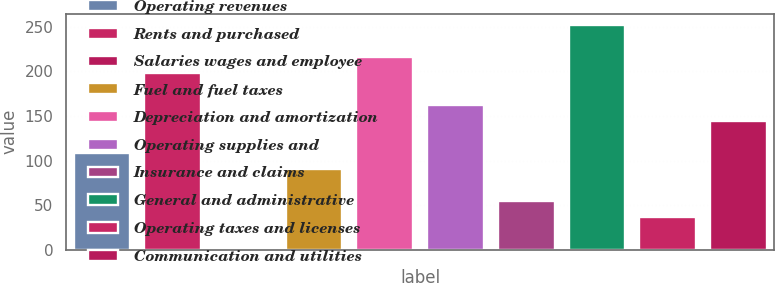Convert chart. <chart><loc_0><loc_0><loc_500><loc_500><bar_chart><fcel>Operating revenues<fcel>Rents and purchased<fcel>Salaries wages and employee<fcel>Fuel and fuel taxes<fcel>Depreciation and amortization<fcel>Operating supplies and<fcel>Insurance and claims<fcel>General and administrative<fcel>Operating taxes and licenses<fcel>Communication and utilities<nl><fcel>108.4<fcel>198.4<fcel>0.4<fcel>90.4<fcel>216.4<fcel>162.4<fcel>54.4<fcel>252.4<fcel>36.4<fcel>144.4<nl></chart> 